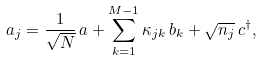Convert formula to latex. <formula><loc_0><loc_0><loc_500><loc_500>a _ { j } = \frac { 1 } { \sqrt { N } } \, a + \sum _ { k = 1 } ^ { M - 1 } \kappa _ { j k } \, b _ { k } + \sqrt { n _ { j } } \, c ^ { \dagger } ,</formula> 